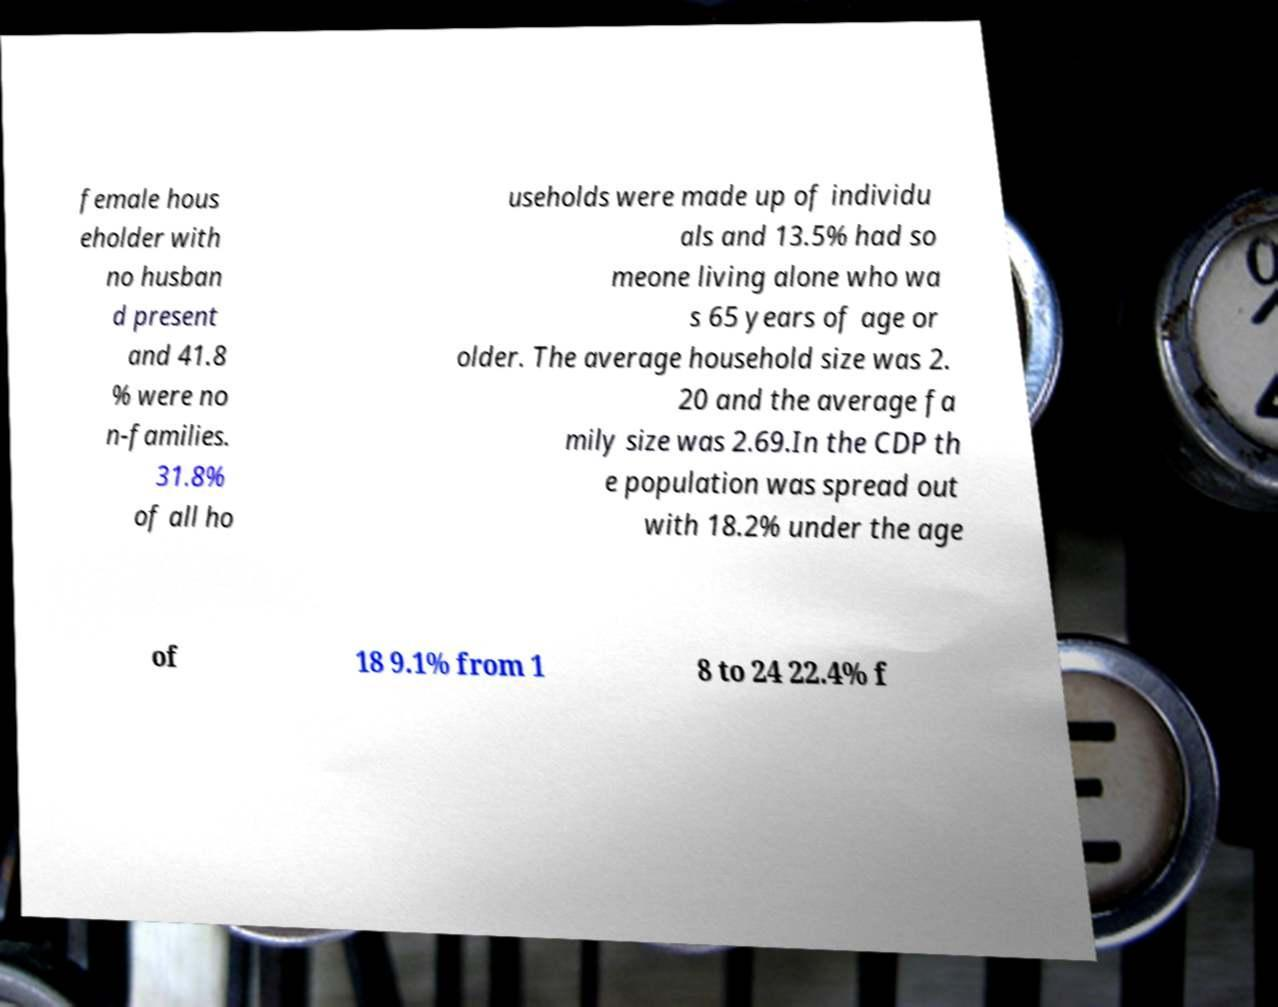There's text embedded in this image that I need extracted. Can you transcribe it verbatim? female hous eholder with no husban d present and 41.8 % were no n-families. 31.8% of all ho useholds were made up of individu als and 13.5% had so meone living alone who wa s 65 years of age or older. The average household size was 2. 20 and the average fa mily size was 2.69.In the CDP th e population was spread out with 18.2% under the age of 18 9.1% from 1 8 to 24 22.4% f 